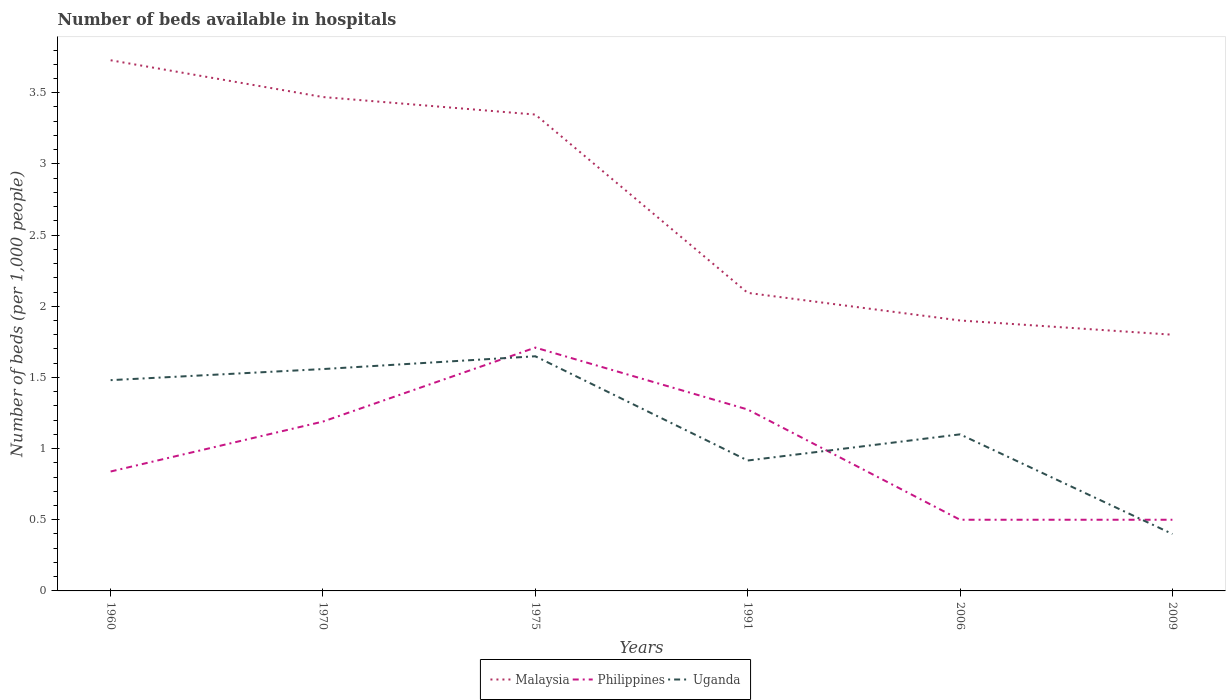How many different coloured lines are there?
Provide a short and direct response. 3. Is the number of lines equal to the number of legend labels?
Ensure brevity in your answer.  Yes. Across all years, what is the maximum number of beds in the hospiatls of in Uganda?
Offer a very short reply. 0.4. What is the total number of beds in the hospiatls of in Malaysia in the graph?
Your answer should be very brief. 0.12. What is the difference between the highest and the second highest number of beds in the hospiatls of in Malaysia?
Offer a terse response. 1.93. What is the difference between the highest and the lowest number of beds in the hospiatls of in Malaysia?
Provide a succinct answer. 3. How many lines are there?
Give a very brief answer. 3. How many years are there in the graph?
Your answer should be very brief. 6. Does the graph contain any zero values?
Make the answer very short. No. Does the graph contain grids?
Give a very brief answer. No. Where does the legend appear in the graph?
Provide a short and direct response. Bottom center. What is the title of the graph?
Make the answer very short. Number of beds available in hospitals. What is the label or title of the Y-axis?
Your response must be concise. Number of beds (per 1,0 people). What is the Number of beds (per 1,000 people) in Malaysia in 1960?
Your answer should be compact. 3.73. What is the Number of beds (per 1,000 people) of Philippines in 1960?
Offer a terse response. 0.84. What is the Number of beds (per 1,000 people) of Uganda in 1960?
Make the answer very short. 1.48. What is the Number of beds (per 1,000 people) in Malaysia in 1970?
Your answer should be very brief. 3.47. What is the Number of beds (per 1,000 people) in Philippines in 1970?
Provide a short and direct response. 1.19. What is the Number of beds (per 1,000 people) of Uganda in 1970?
Your answer should be compact. 1.56. What is the Number of beds (per 1,000 people) of Malaysia in 1975?
Keep it short and to the point. 3.35. What is the Number of beds (per 1,000 people) of Philippines in 1975?
Your response must be concise. 1.71. What is the Number of beds (per 1,000 people) in Uganda in 1975?
Provide a succinct answer. 1.65. What is the Number of beds (per 1,000 people) in Malaysia in 1991?
Offer a terse response. 2.09. What is the Number of beds (per 1,000 people) of Philippines in 1991?
Ensure brevity in your answer.  1.27. What is the Number of beds (per 1,000 people) in Uganda in 1991?
Provide a succinct answer. 0.92. What is the Number of beds (per 1,000 people) of Malaysia in 2006?
Give a very brief answer. 1.9. What is the Number of beds (per 1,000 people) in Malaysia in 2009?
Ensure brevity in your answer.  1.8. Across all years, what is the maximum Number of beds (per 1,000 people) in Malaysia?
Your answer should be compact. 3.73. Across all years, what is the maximum Number of beds (per 1,000 people) in Philippines?
Provide a short and direct response. 1.71. Across all years, what is the maximum Number of beds (per 1,000 people) of Uganda?
Provide a succinct answer. 1.65. Across all years, what is the minimum Number of beds (per 1,000 people) in Philippines?
Your response must be concise. 0.5. Across all years, what is the minimum Number of beds (per 1,000 people) in Uganda?
Ensure brevity in your answer.  0.4. What is the total Number of beds (per 1,000 people) in Malaysia in the graph?
Offer a terse response. 16.34. What is the total Number of beds (per 1,000 people) of Philippines in the graph?
Offer a terse response. 6.01. What is the total Number of beds (per 1,000 people) of Uganda in the graph?
Give a very brief answer. 7.1. What is the difference between the Number of beds (per 1,000 people) of Malaysia in 1960 and that in 1970?
Offer a very short reply. 0.26. What is the difference between the Number of beds (per 1,000 people) of Philippines in 1960 and that in 1970?
Make the answer very short. -0.35. What is the difference between the Number of beds (per 1,000 people) of Uganda in 1960 and that in 1970?
Offer a very short reply. -0.08. What is the difference between the Number of beds (per 1,000 people) in Malaysia in 1960 and that in 1975?
Offer a terse response. 0.38. What is the difference between the Number of beds (per 1,000 people) in Philippines in 1960 and that in 1975?
Your response must be concise. -0.87. What is the difference between the Number of beds (per 1,000 people) in Uganda in 1960 and that in 1975?
Your response must be concise. -0.17. What is the difference between the Number of beds (per 1,000 people) of Malaysia in 1960 and that in 1991?
Your answer should be very brief. 1.63. What is the difference between the Number of beds (per 1,000 people) of Philippines in 1960 and that in 1991?
Ensure brevity in your answer.  -0.44. What is the difference between the Number of beds (per 1,000 people) in Uganda in 1960 and that in 1991?
Your answer should be compact. 0.56. What is the difference between the Number of beds (per 1,000 people) of Malaysia in 1960 and that in 2006?
Ensure brevity in your answer.  1.83. What is the difference between the Number of beds (per 1,000 people) of Philippines in 1960 and that in 2006?
Provide a succinct answer. 0.34. What is the difference between the Number of beds (per 1,000 people) in Uganda in 1960 and that in 2006?
Your answer should be very brief. 0.38. What is the difference between the Number of beds (per 1,000 people) in Malaysia in 1960 and that in 2009?
Provide a short and direct response. 1.93. What is the difference between the Number of beds (per 1,000 people) in Philippines in 1960 and that in 2009?
Give a very brief answer. 0.34. What is the difference between the Number of beds (per 1,000 people) in Uganda in 1960 and that in 2009?
Provide a succinct answer. 1.08. What is the difference between the Number of beds (per 1,000 people) of Malaysia in 1970 and that in 1975?
Your response must be concise. 0.12. What is the difference between the Number of beds (per 1,000 people) of Philippines in 1970 and that in 1975?
Give a very brief answer. -0.52. What is the difference between the Number of beds (per 1,000 people) of Uganda in 1970 and that in 1975?
Offer a terse response. -0.09. What is the difference between the Number of beds (per 1,000 people) of Malaysia in 1970 and that in 1991?
Offer a terse response. 1.38. What is the difference between the Number of beds (per 1,000 people) in Philippines in 1970 and that in 1991?
Give a very brief answer. -0.08. What is the difference between the Number of beds (per 1,000 people) in Uganda in 1970 and that in 1991?
Make the answer very short. 0.64. What is the difference between the Number of beds (per 1,000 people) of Malaysia in 1970 and that in 2006?
Give a very brief answer. 1.57. What is the difference between the Number of beds (per 1,000 people) of Philippines in 1970 and that in 2006?
Your response must be concise. 0.69. What is the difference between the Number of beds (per 1,000 people) of Uganda in 1970 and that in 2006?
Keep it short and to the point. 0.46. What is the difference between the Number of beds (per 1,000 people) of Malaysia in 1970 and that in 2009?
Give a very brief answer. 1.67. What is the difference between the Number of beds (per 1,000 people) in Philippines in 1970 and that in 2009?
Provide a succinct answer. 0.69. What is the difference between the Number of beds (per 1,000 people) of Uganda in 1970 and that in 2009?
Provide a succinct answer. 1.16. What is the difference between the Number of beds (per 1,000 people) of Malaysia in 1975 and that in 1991?
Give a very brief answer. 1.25. What is the difference between the Number of beds (per 1,000 people) of Philippines in 1975 and that in 1991?
Make the answer very short. 0.43. What is the difference between the Number of beds (per 1,000 people) in Uganda in 1975 and that in 1991?
Your answer should be very brief. 0.73. What is the difference between the Number of beds (per 1,000 people) in Malaysia in 1975 and that in 2006?
Offer a very short reply. 1.45. What is the difference between the Number of beds (per 1,000 people) in Philippines in 1975 and that in 2006?
Ensure brevity in your answer.  1.21. What is the difference between the Number of beds (per 1,000 people) in Uganda in 1975 and that in 2006?
Your answer should be very brief. 0.55. What is the difference between the Number of beds (per 1,000 people) of Malaysia in 1975 and that in 2009?
Provide a short and direct response. 1.55. What is the difference between the Number of beds (per 1,000 people) in Philippines in 1975 and that in 2009?
Your answer should be compact. 1.21. What is the difference between the Number of beds (per 1,000 people) in Uganda in 1975 and that in 2009?
Ensure brevity in your answer.  1.25. What is the difference between the Number of beds (per 1,000 people) of Malaysia in 1991 and that in 2006?
Provide a succinct answer. 0.19. What is the difference between the Number of beds (per 1,000 people) of Philippines in 1991 and that in 2006?
Make the answer very short. 0.77. What is the difference between the Number of beds (per 1,000 people) in Uganda in 1991 and that in 2006?
Provide a succinct answer. -0.18. What is the difference between the Number of beds (per 1,000 people) in Malaysia in 1991 and that in 2009?
Give a very brief answer. 0.29. What is the difference between the Number of beds (per 1,000 people) in Philippines in 1991 and that in 2009?
Offer a terse response. 0.77. What is the difference between the Number of beds (per 1,000 people) in Uganda in 1991 and that in 2009?
Ensure brevity in your answer.  0.52. What is the difference between the Number of beds (per 1,000 people) of Malaysia in 2006 and that in 2009?
Your response must be concise. 0.1. What is the difference between the Number of beds (per 1,000 people) in Philippines in 2006 and that in 2009?
Provide a succinct answer. 0. What is the difference between the Number of beds (per 1,000 people) in Uganda in 2006 and that in 2009?
Provide a succinct answer. 0.7. What is the difference between the Number of beds (per 1,000 people) of Malaysia in 1960 and the Number of beds (per 1,000 people) of Philippines in 1970?
Make the answer very short. 2.54. What is the difference between the Number of beds (per 1,000 people) in Malaysia in 1960 and the Number of beds (per 1,000 people) in Uganda in 1970?
Your answer should be compact. 2.17. What is the difference between the Number of beds (per 1,000 people) in Philippines in 1960 and the Number of beds (per 1,000 people) in Uganda in 1970?
Offer a very short reply. -0.72. What is the difference between the Number of beds (per 1,000 people) of Malaysia in 1960 and the Number of beds (per 1,000 people) of Philippines in 1975?
Make the answer very short. 2.02. What is the difference between the Number of beds (per 1,000 people) of Malaysia in 1960 and the Number of beds (per 1,000 people) of Uganda in 1975?
Give a very brief answer. 2.08. What is the difference between the Number of beds (per 1,000 people) of Philippines in 1960 and the Number of beds (per 1,000 people) of Uganda in 1975?
Your answer should be compact. -0.81. What is the difference between the Number of beds (per 1,000 people) of Malaysia in 1960 and the Number of beds (per 1,000 people) of Philippines in 1991?
Your answer should be very brief. 2.45. What is the difference between the Number of beds (per 1,000 people) in Malaysia in 1960 and the Number of beds (per 1,000 people) in Uganda in 1991?
Keep it short and to the point. 2.81. What is the difference between the Number of beds (per 1,000 people) of Philippines in 1960 and the Number of beds (per 1,000 people) of Uganda in 1991?
Offer a terse response. -0.08. What is the difference between the Number of beds (per 1,000 people) of Malaysia in 1960 and the Number of beds (per 1,000 people) of Philippines in 2006?
Give a very brief answer. 3.23. What is the difference between the Number of beds (per 1,000 people) of Malaysia in 1960 and the Number of beds (per 1,000 people) of Uganda in 2006?
Offer a very short reply. 2.63. What is the difference between the Number of beds (per 1,000 people) in Philippines in 1960 and the Number of beds (per 1,000 people) in Uganda in 2006?
Your answer should be very brief. -0.26. What is the difference between the Number of beds (per 1,000 people) of Malaysia in 1960 and the Number of beds (per 1,000 people) of Philippines in 2009?
Provide a short and direct response. 3.23. What is the difference between the Number of beds (per 1,000 people) in Malaysia in 1960 and the Number of beds (per 1,000 people) in Uganda in 2009?
Provide a short and direct response. 3.33. What is the difference between the Number of beds (per 1,000 people) in Philippines in 1960 and the Number of beds (per 1,000 people) in Uganda in 2009?
Provide a succinct answer. 0.44. What is the difference between the Number of beds (per 1,000 people) in Malaysia in 1970 and the Number of beds (per 1,000 people) in Philippines in 1975?
Make the answer very short. 1.76. What is the difference between the Number of beds (per 1,000 people) of Malaysia in 1970 and the Number of beds (per 1,000 people) of Uganda in 1975?
Provide a succinct answer. 1.82. What is the difference between the Number of beds (per 1,000 people) of Philippines in 1970 and the Number of beds (per 1,000 people) of Uganda in 1975?
Ensure brevity in your answer.  -0.46. What is the difference between the Number of beds (per 1,000 people) of Malaysia in 1970 and the Number of beds (per 1,000 people) of Philippines in 1991?
Make the answer very short. 2.2. What is the difference between the Number of beds (per 1,000 people) of Malaysia in 1970 and the Number of beds (per 1,000 people) of Uganda in 1991?
Ensure brevity in your answer.  2.55. What is the difference between the Number of beds (per 1,000 people) of Philippines in 1970 and the Number of beds (per 1,000 people) of Uganda in 1991?
Make the answer very short. 0.27. What is the difference between the Number of beds (per 1,000 people) of Malaysia in 1970 and the Number of beds (per 1,000 people) of Philippines in 2006?
Ensure brevity in your answer.  2.97. What is the difference between the Number of beds (per 1,000 people) in Malaysia in 1970 and the Number of beds (per 1,000 people) in Uganda in 2006?
Offer a very short reply. 2.37. What is the difference between the Number of beds (per 1,000 people) in Philippines in 1970 and the Number of beds (per 1,000 people) in Uganda in 2006?
Offer a very short reply. 0.09. What is the difference between the Number of beds (per 1,000 people) in Malaysia in 1970 and the Number of beds (per 1,000 people) in Philippines in 2009?
Your response must be concise. 2.97. What is the difference between the Number of beds (per 1,000 people) in Malaysia in 1970 and the Number of beds (per 1,000 people) in Uganda in 2009?
Provide a succinct answer. 3.07. What is the difference between the Number of beds (per 1,000 people) of Philippines in 1970 and the Number of beds (per 1,000 people) of Uganda in 2009?
Offer a very short reply. 0.79. What is the difference between the Number of beds (per 1,000 people) in Malaysia in 1975 and the Number of beds (per 1,000 people) in Philippines in 1991?
Ensure brevity in your answer.  2.07. What is the difference between the Number of beds (per 1,000 people) in Malaysia in 1975 and the Number of beds (per 1,000 people) in Uganda in 1991?
Offer a terse response. 2.43. What is the difference between the Number of beds (per 1,000 people) of Philippines in 1975 and the Number of beds (per 1,000 people) of Uganda in 1991?
Ensure brevity in your answer.  0.79. What is the difference between the Number of beds (per 1,000 people) of Malaysia in 1975 and the Number of beds (per 1,000 people) of Philippines in 2006?
Keep it short and to the point. 2.85. What is the difference between the Number of beds (per 1,000 people) in Malaysia in 1975 and the Number of beds (per 1,000 people) in Uganda in 2006?
Keep it short and to the point. 2.25. What is the difference between the Number of beds (per 1,000 people) of Philippines in 1975 and the Number of beds (per 1,000 people) of Uganda in 2006?
Your response must be concise. 0.61. What is the difference between the Number of beds (per 1,000 people) in Malaysia in 1975 and the Number of beds (per 1,000 people) in Philippines in 2009?
Provide a succinct answer. 2.85. What is the difference between the Number of beds (per 1,000 people) of Malaysia in 1975 and the Number of beds (per 1,000 people) of Uganda in 2009?
Provide a short and direct response. 2.95. What is the difference between the Number of beds (per 1,000 people) in Philippines in 1975 and the Number of beds (per 1,000 people) in Uganda in 2009?
Your answer should be very brief. 1.31. What is the difference between the Number of beds (per 1,000 people) in Malaysia in 1991 and the Number of beds (per 1,000 people) in Philippines in 2006?
Give a very brief answer. 1.59. What is the difference between the Number of beds (per 1,000 people) in Malaysia in 1991 and the Number of beds (per 1,000 people) in Uganda in 2006?
Ensure brevity in your answer.  0.99. What is the difference between the Number of beds (per 1,000 people) of Philippines in 1991 and the Number of beds (per 1,000 people) of Uganda in 2006?
Give a very brief answer. 0.17. What is the difference between the Number of beds (per 1,000 people) in Malaysia in 1991 and the Number of beds (per 1,000 people) in Philippines in 2009?
Keep it short and to the point. 1.59. What is the difference between the Number of beds (per 1,000 people) of Malaysia in 1991 and the Number of beds (per 1,000 people) of Uganda in 2009?
Your response must be concise. 1.69. What is the difference between the Number of beds (per 1,000 people) of Philippines in 1991 and the Number of beds (per 1,000 people) of Uganda in 2009?
Keep it short and to the point. 0.87. What is the difference between the Number of beds (per 1,000 people) in Malaysia in 2006 and the Number of beds (per 1,000 people) in Philippines in 2009?
Ensure brevity in your answer.  1.4. What is the difference between the Number of beds (per 1,000 people) of Philippines in 2006 and the Number of beds (per 1,000 people) of Uganda in 2009?
Ensure brevity in your answer.  0.1. What is the average Number of beds (per 1,000 people) in Malaysia per year?
Offer a terse response. 2.72. What is the average Number of beds (per 1,000 people) in Uganda per year?
Offer a very short reply. 1.18. In the year 1960, what is the difference between the Number of beds (per 1,000 people) of Malaysia and Number of beds (per 1,000 people) of Philippines?
Keep it short and to the point. 2.89. In the year 1960, what is the difference between the Number of beds (per 1,000 people) in Malaysia and Number of beds (per 1,000 people) in Uganda?
Make the answer very short. 2.25. In the year 1960, what is the difference between the Number of beds (per 1,000 people) in Philippines and Number of beds (per 1,000 people) in Uganda?
Your answer should be compact. -0.64. In the year 1970, what is the difference between the Number of beds (per 1,000 people) in Malaysia and Number of beds (per 1,000 people) in Philippines?
Offer a very short reply. 2.28. In the year 1970, what is the difference between the Number of beds (per 1,000 people) in Malaysia and Number of beds (per 1,000 people) in Uganda?
Give a very brief answer. 1.91. In the year 1970, what is the difference between the Number of beds (per 1,000 people) of Philippines and Number of beds (per 1,000 people) of Uganda?
Provide a succinct answer. -0.37. In the year 1975, what is the difference between the Number of beds (per 1,000 people) in Malaysia and Number of beds (per 1,000 people) in Philippines?
Your response must be concise. 1.64. In the year 1975, what is the difference between the Number of beds (per 1,000 people) in Malaysia and Number of beds (per 1,000 people) in Uganda?
Keep it short and to the point. 1.7. In the year 1975, what is the difference between the Number of beds (per 1,000 people) in Philippines and Number of beds (per 1,000 people) in Uganda?
Offer a very short reply. 0.06. In the year 1991, what is the difference between the Number of beds (per 1,000 people) of Malaysia and Number of beds (per 1,000 people) of Philippines?
Your answer should be very brief. 0.82. In the year 1991, what is the difference between the Number of beds (per 1,000 people) of Malaysia and Number of beds (per 1,000 people) of Uganda?
Offer a terse response. 1.18. In the year 1991, what is the difference between the Number of beds (per 1,000 people) of Philippines and Number of beds (per 1,000 people) of Uganda?
Provide a succinct answer. 0.36. In the year 2006, what is the difference between the Number of beds (per 1,000 people) in Malaysia and Number of beds (per 1,000 people) in Uganda?
Provide a succinct answer. 0.8. In the year 2009, what is the difference between the Number of beds (per 1,000 people) of Malaysia and Number of beds (per 1,000 people) of Philippines?
Give a very brief answer. 1.3. In the year 2009, what is the difference between the Number of beds (per 1,000 people) in Malaysia and Number of beds (per 1,000 people) in Uganda?
Make the answer very short. 1.4. In the year 2009, what is the difference between the Number of beds (per 1,000 people) in Philippines and Number of beds (per 1,000 people) in Uganda?
Offer a very short reply. 0.1. What is the ratio of the Number of beds (per 1,000 people) of Malaysia in 1960 to that in 1970?
Your answer should be compact. 1.07. What is the ratio of the Number of beds (per 1,000 people) of Philippines in 1960 to that in 1970?
Make the answer very short. 0.71. What is the ratio of the Number of beds (per 1,000 people) of Malaysia in 1960 to that in 1975?
Offer a very short reply. 1.11. What is the ratio of the Number of beds (per 1,000 people) of Philippines in 1960 to that in 1975?
Keep it short and to the point. 0.49. What is the ratio of the Number of beds (per 1,000 people) of Uganda in 1960 to that in 1975?
Your response must be concise. 0.9. What is the ratio of the Number of beds (per 1,000 people) in Malaysia in 1960 to that in 1991?
Your answer should be very brief. 1.78. What is the ratio of the Number of beds (per 1,000 people) of Philippines in 1960 to that in 1991?
Keep it short and to the point. 0.66. What is the ratio of the Number of beds (per 1,000 people) in Uganda in 1960 to that in 1991?
Your answer should be very brief. 1.62. What is the ratio of the Number of beds (per 1,000 people) in Malaysia in 1960 to that in 2006?
Ensure brevity in your answer.  1.96. What is the ratio of the Number of beds (per 1,000 people) in Philippines in 1960 to that in 2006?
Offer a terse response. 1.68. What is the ratio of the Number of beds (per 1,000 people) of Uganda in 1960 to that in 2006?
Provide a succinct answer. 1.35. What is the ratio of the Number of beds (per 1,000 people) in Malaysia in 1960 to that in 2009?
Offer a very short reply. 2.07. What is the ratio of the Number of beds (per 1,000 people) of Philippines in 1960 to that in 2009?
Ensure brevity in your answer.  1.68. What is the ratio of the Number of beds (per 1,000 people) in Uganda in 1960 to that in 2009?
Provide a succinct answer. 3.7. What is the ratio of the Number of beds (per 1,000 people) of Malaysia in 1970 to that in 1975?
Give a very brief answer. 1.04. What is the ratio of the Number of beds (per 1,000 people) of Philippines in 1970 to that in 1975?
Keep it short and to the point. 0.7. What is the ratio of the Number of beds (per 1,000 people) in Uganda in 1970 to that in 1975?
Give a very brief answer. 0.95. What is the ratio of the Number of beds (per 1,000 people) in Malaysia in 1970 to that in 1991?
Give a very brief answer. 1.66. What is the ratio of the Number of beds (per 1,000 people) of Philippines in 1970 to that in 1991?
Ensure brevity in your answer.  0.93. What is the ratio of the Number of beds (per 1,000 people) of Uganda in 1970 to that in 1991?
Ensure brevity in your answer.  1.7. What is the ratio of the Number of beds (per 1,000 people) in Malaysia in 1970 to that in 2006?
Offer a very short reply. 1.83. What is the ratio of the Number of beds (per 1,000 people) in Philippines in 1970 to that in 2006?
Provide a succinct answer. 2.38. What is the ratio of the Number of beds (per 1,000 people) of Uganda in 1970 to that in 2006?
Provide a succinct answer. 1.42. What is the ratio of the Number of beds (per 1,000 people) in Malaysia in 1970 to that in 2009?
Your response must be concise. 1.93. What is the ratio of the Number of beds (per 1,000 people) in Philippines in 1970 to that in 2009?
Provide a short and direct response. 2.38. What is the ratio of the Number of beds (per 1,000 people) of Uganda in 1970 to that in 2009?
Make the answer very short. 3.9. What is the ratio of the Number of beds (per 1,000 people) in Malaysia in 1975 to that in 1991?
Make the answer very short. 1.6. What is the ratio of the Number of beds (per 1,000 people) of Philippines in 1975 to that in 1991?
Your answer should be compact. 1.34. What is the ratio of the Number of beds (per 1,000 people) in Uganda in 1975 to that in 1991?
Your response must be concise. 1.8. What is the ratio of the Number of beds (per 1,000 people) in Malaysia in 1975 to that in 2006?
Make the answer very short. 1.76. What is the ratio of the Number of beds (per 1,000 people) of Philippines in 1975 to that in 2006?
Give a very brief answer. 3.42. What is the ratio of the Number of beds (per 1,000 people) of Uganda in 1975 to that in 2006?
Offer a terse response. 1.5. What is the ratio of the Number of beds (per 1,000 people) of Malaysia in 1975 to that in 2009?
Your answer should be compact. 1.86. What is the ratio of the Number of beds (per 1,000 people) of Philippines in 1975 to that in 2009?
Offer a very short reply. 3.42. What is the ratio of the Number of beds (per 1,000 people) in Uganda in 1975 to that in 2009?
Keep it short and to the point. 4.12. What is the ratio of the Number of beds (per 1,000 people) in Malaysia in 1991 to that in 2006?
Provide a short and direct response. 1.1. What is the ratio of the Number of beds (per 1,000 people) of Philippines in 1991 to that in 2006?
Your answer should be compact. 2.55. What is the ratio of the Number of beds (per 1,000 people) of Uganda in 1991 to that in 2006?
Offer a terse response. 0.83. What is the ratio of the Number of beds (per 1,000 people) in Malaysia in 1991 to that in 2009?
Provide a short and direct response. 1.16. What is the ratio of the Number of beds (per 1,000 people) in Philippines in 1991 to that in 2009?
Your answer should be very brief. 2.55. What is the ratio of the Number of beds (per 1,000 people) of Uganda in 1991 to that in 2009?
Your answer should be very brief. 2.29. What is the ratio of the Number of beds (per 1,000 people) in Malaysia in 2006 to that in 2009?
Your answer should be very brief. 1.06. What is the ratio of the Number of beds (per 1,000 people) of Uganda in 2006 to that in 2009?
Make the answer very short. 2.75. What is the difference between the highest and the second highest Number of beds (per 1,000 people) in Malaysia?
Offer a very short reply. 0.26. What is the difference between the highest and the second highest Number of beds (per 1,000 people) in Philippines?
Your answer should be compact. 0.43. What is the difference between the highest and the second highest Number of beds (per 1,000 people) of Uganda?
Provide a succinct answer. 0.09. What is the difference between the highest and the lowest Number of beds (per 1,000 people) of Malaysia?
Offer a very short reply. 1.93. What is the difference between the highest and the lowest Number of beds (per 1,000 people) in Philippines?
Your answer should be compact. 1.21. What is the difference between the highest and the lowest Number of beds (per 1,000 people) in Uganda?
Your response must be concise. 1.25. 